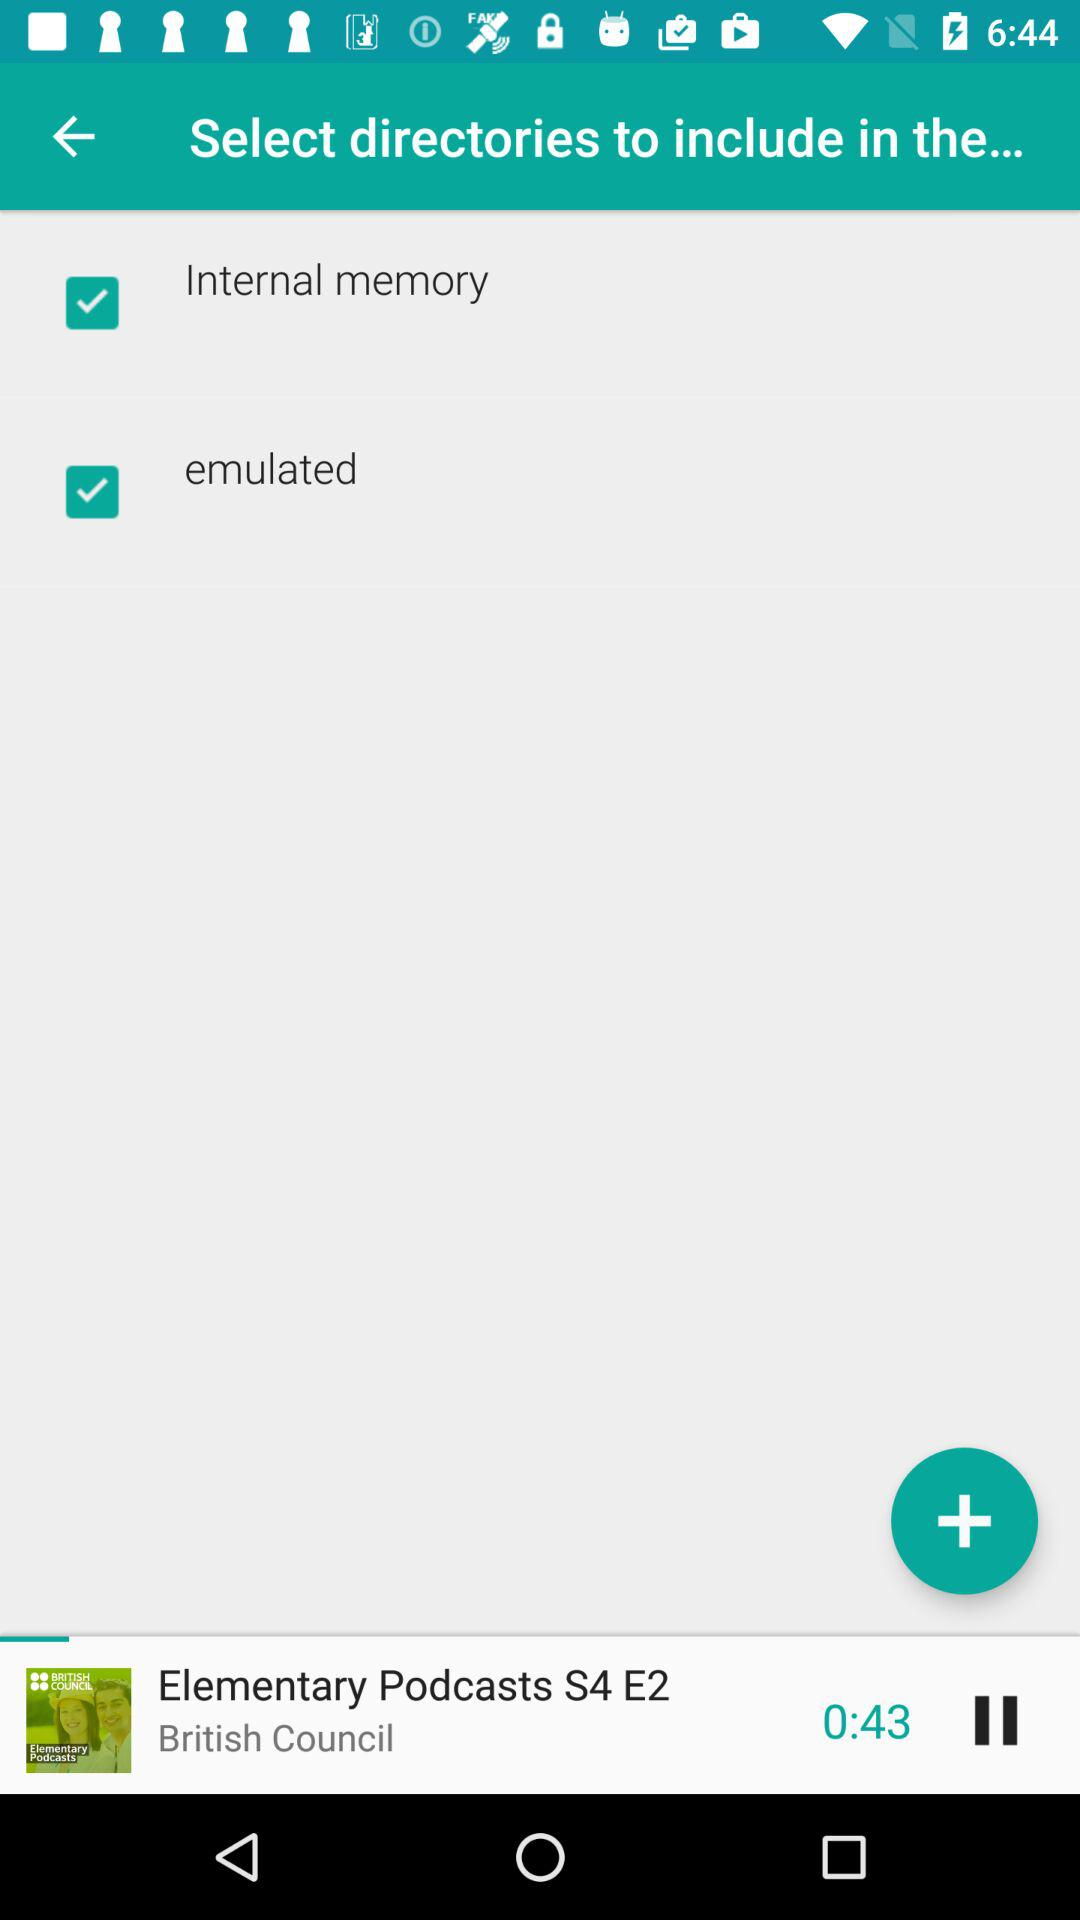How many minutes long is the podcast?
Answer the question using a single word or phrase. 0:43 